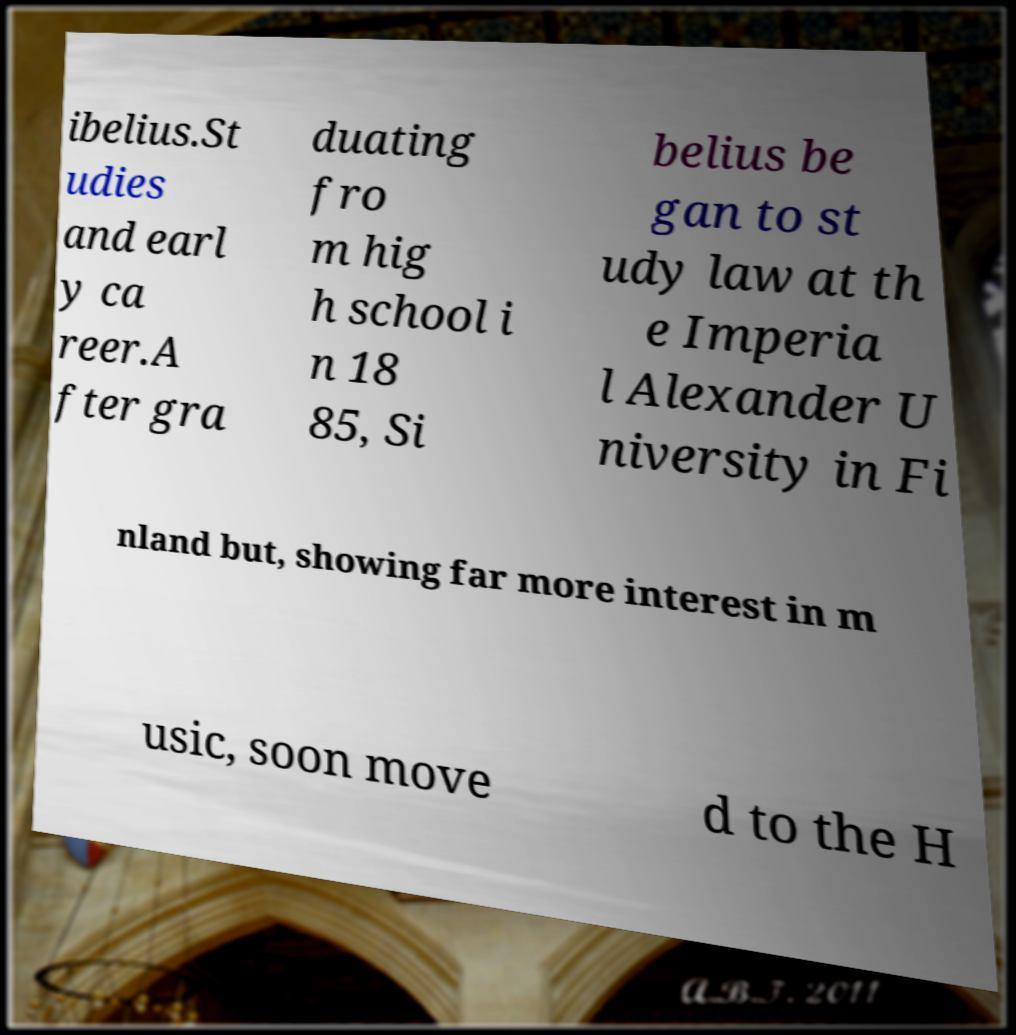Please read and relay the text visible in this image. What does it say? ibelius.St udies and earl y ca reer.A fter gra duating fro m hig h school i n 18 85, Si belius be gan to st udy law at th e Imperia l Alexander U niversity in Fi nland but, showing far more interest in m usic, soon move d to the H 